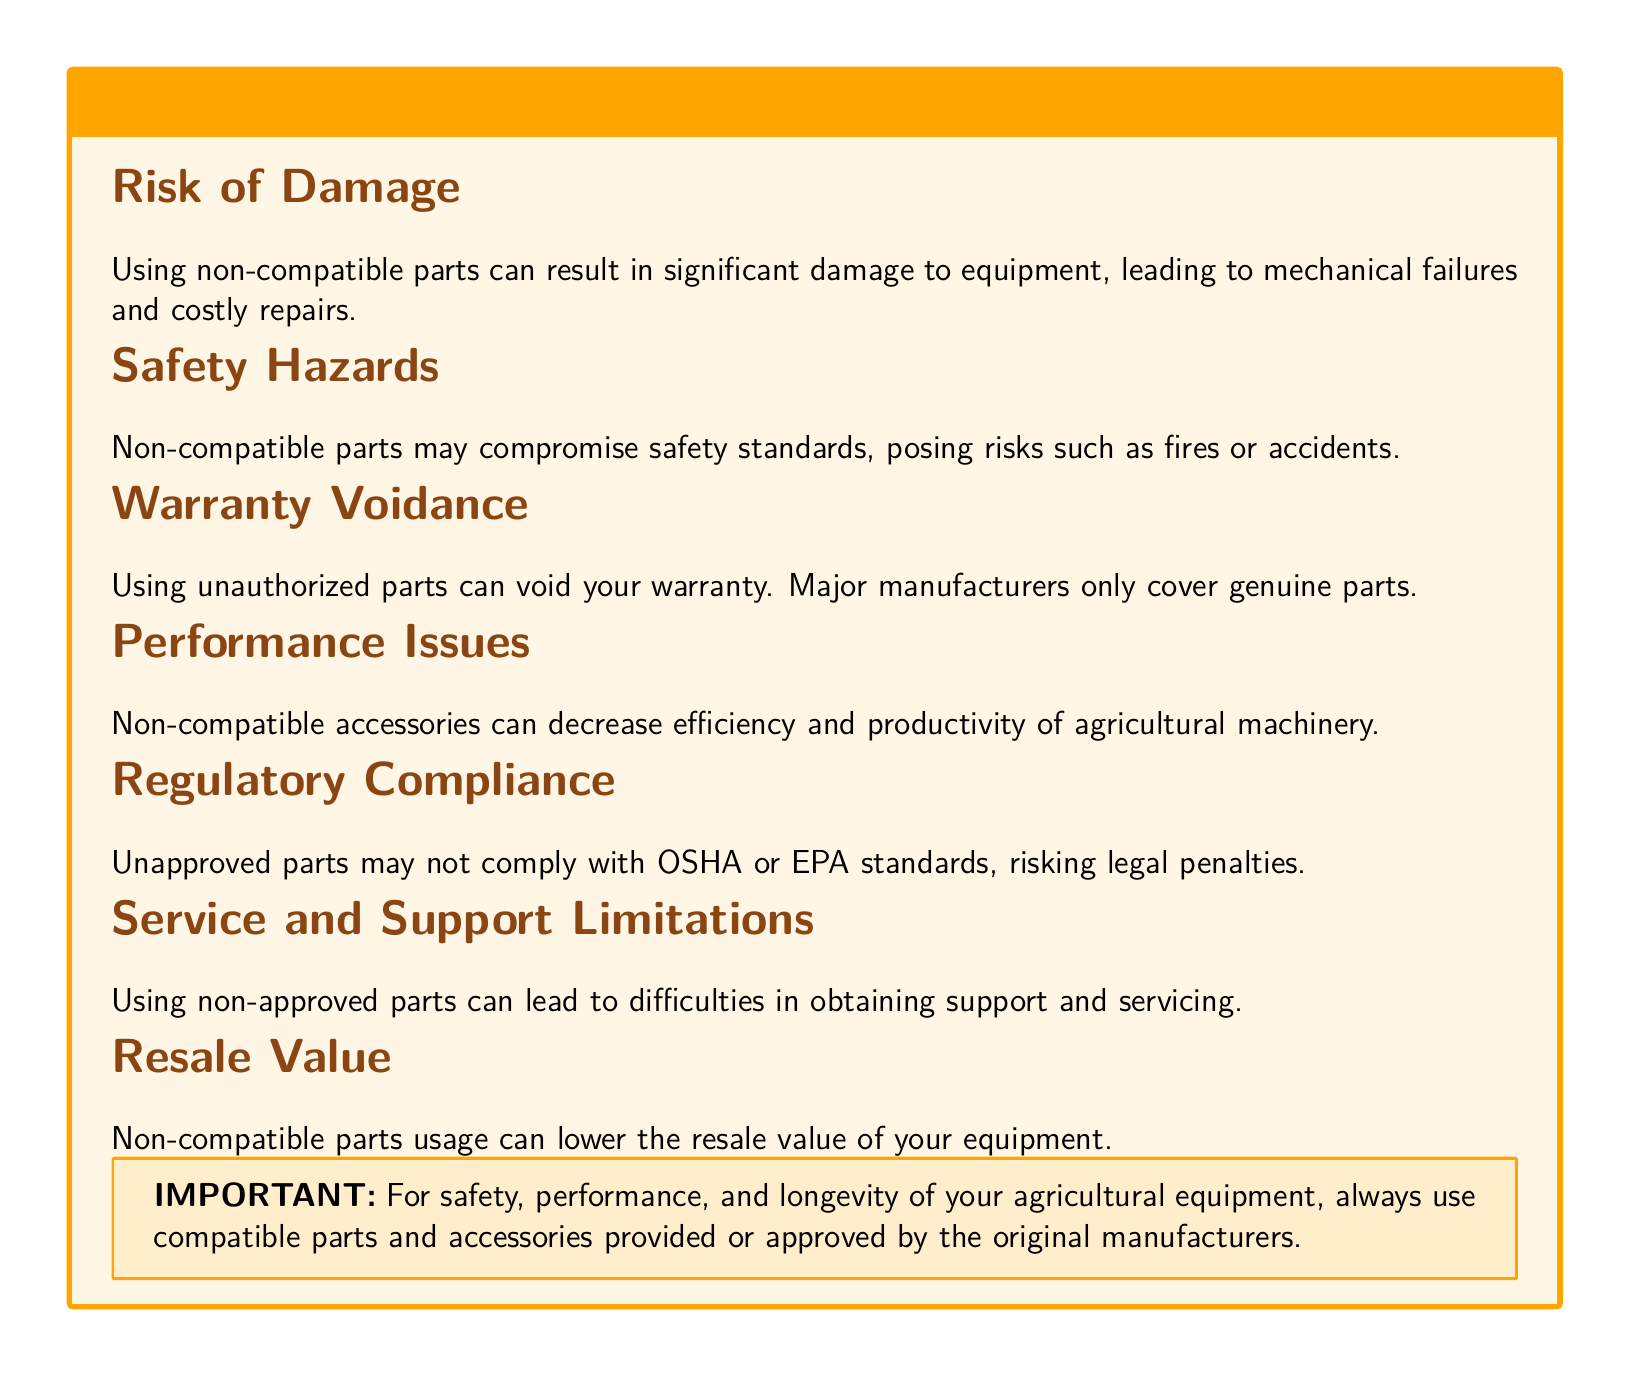What is the main warning in this document? The main warning is about the risks associated with using non-compatible parts and accessories.
Answer: Non-Compatible Parts and Accessories What can using non-compatible parts lead to? The document states that using non-compatible parts can lead to significant damage to equipment.
Answer: Significant damage What are two safety hazards mentioned? The document lists risks such as fires or accidents as safety hazards posed by non-compatible parts.
Answer: Fires, accidents What happens to your warranty when unauthorized parts are used? The document explicitly states that using unauthorized parts can void your warranty.
Answer: Void your warranty What standard compliance may be at risk when unapproved parts are used? The document mentions compliance with OSHA or EPA standards that may be at risk.
Answer: OSHA or EPA standards How can non-compatible accessories affect machinery performance? The document indicates that non-compatible accessories can decrease efficiency and productivity of agricultural machinery.
Answer: Decrease efficiency and productivity What is one consequence of using non-approved parts regarding service? The document states that difficulties in obtaining support and servicing can result from using non-approved parts.
Answer: Difficulties in obtaining support What can be affected in terms of the equipment's future value? The document states that the resale value of the equipment can be lowered by using non-compatible parts.
Answer: Resale value 